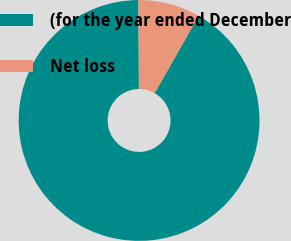Convert chart to OTSL. <chart><loc_0><loc_0><loc_500><loc_500><pie_chart><fcel>(for the year ended December<fcel>Net loss<nl><fcel>91.67%<fcel>8.33%<nl></chart> 